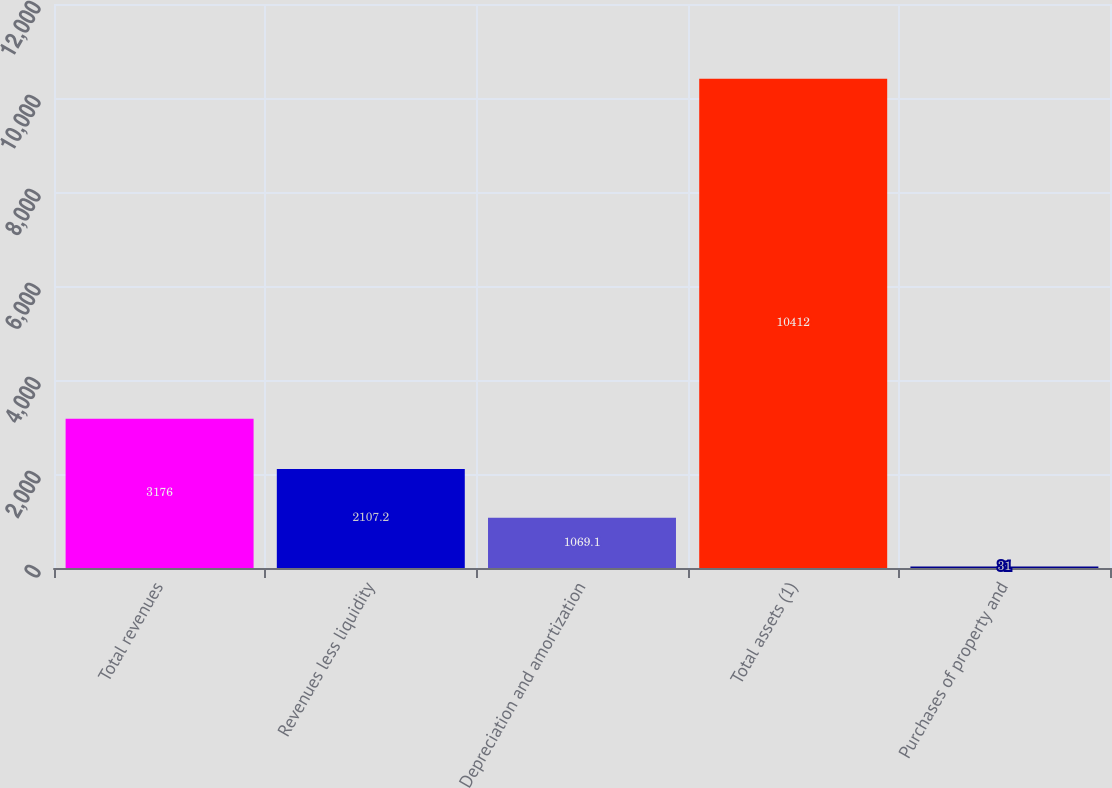<chart> <loc_0><loc_0><loc_500><loc_500><bar_chart><fcel>Total revenues<fcel>Revenues less liquidity<fcel>Depreciation and amortization<fcel>Total assets (1)<fcel>Purchases of property and<nl><fcel>3176<fcel>2107.2<fcel>1069.1<fcel>10412<fcel>31<nl></chart> 